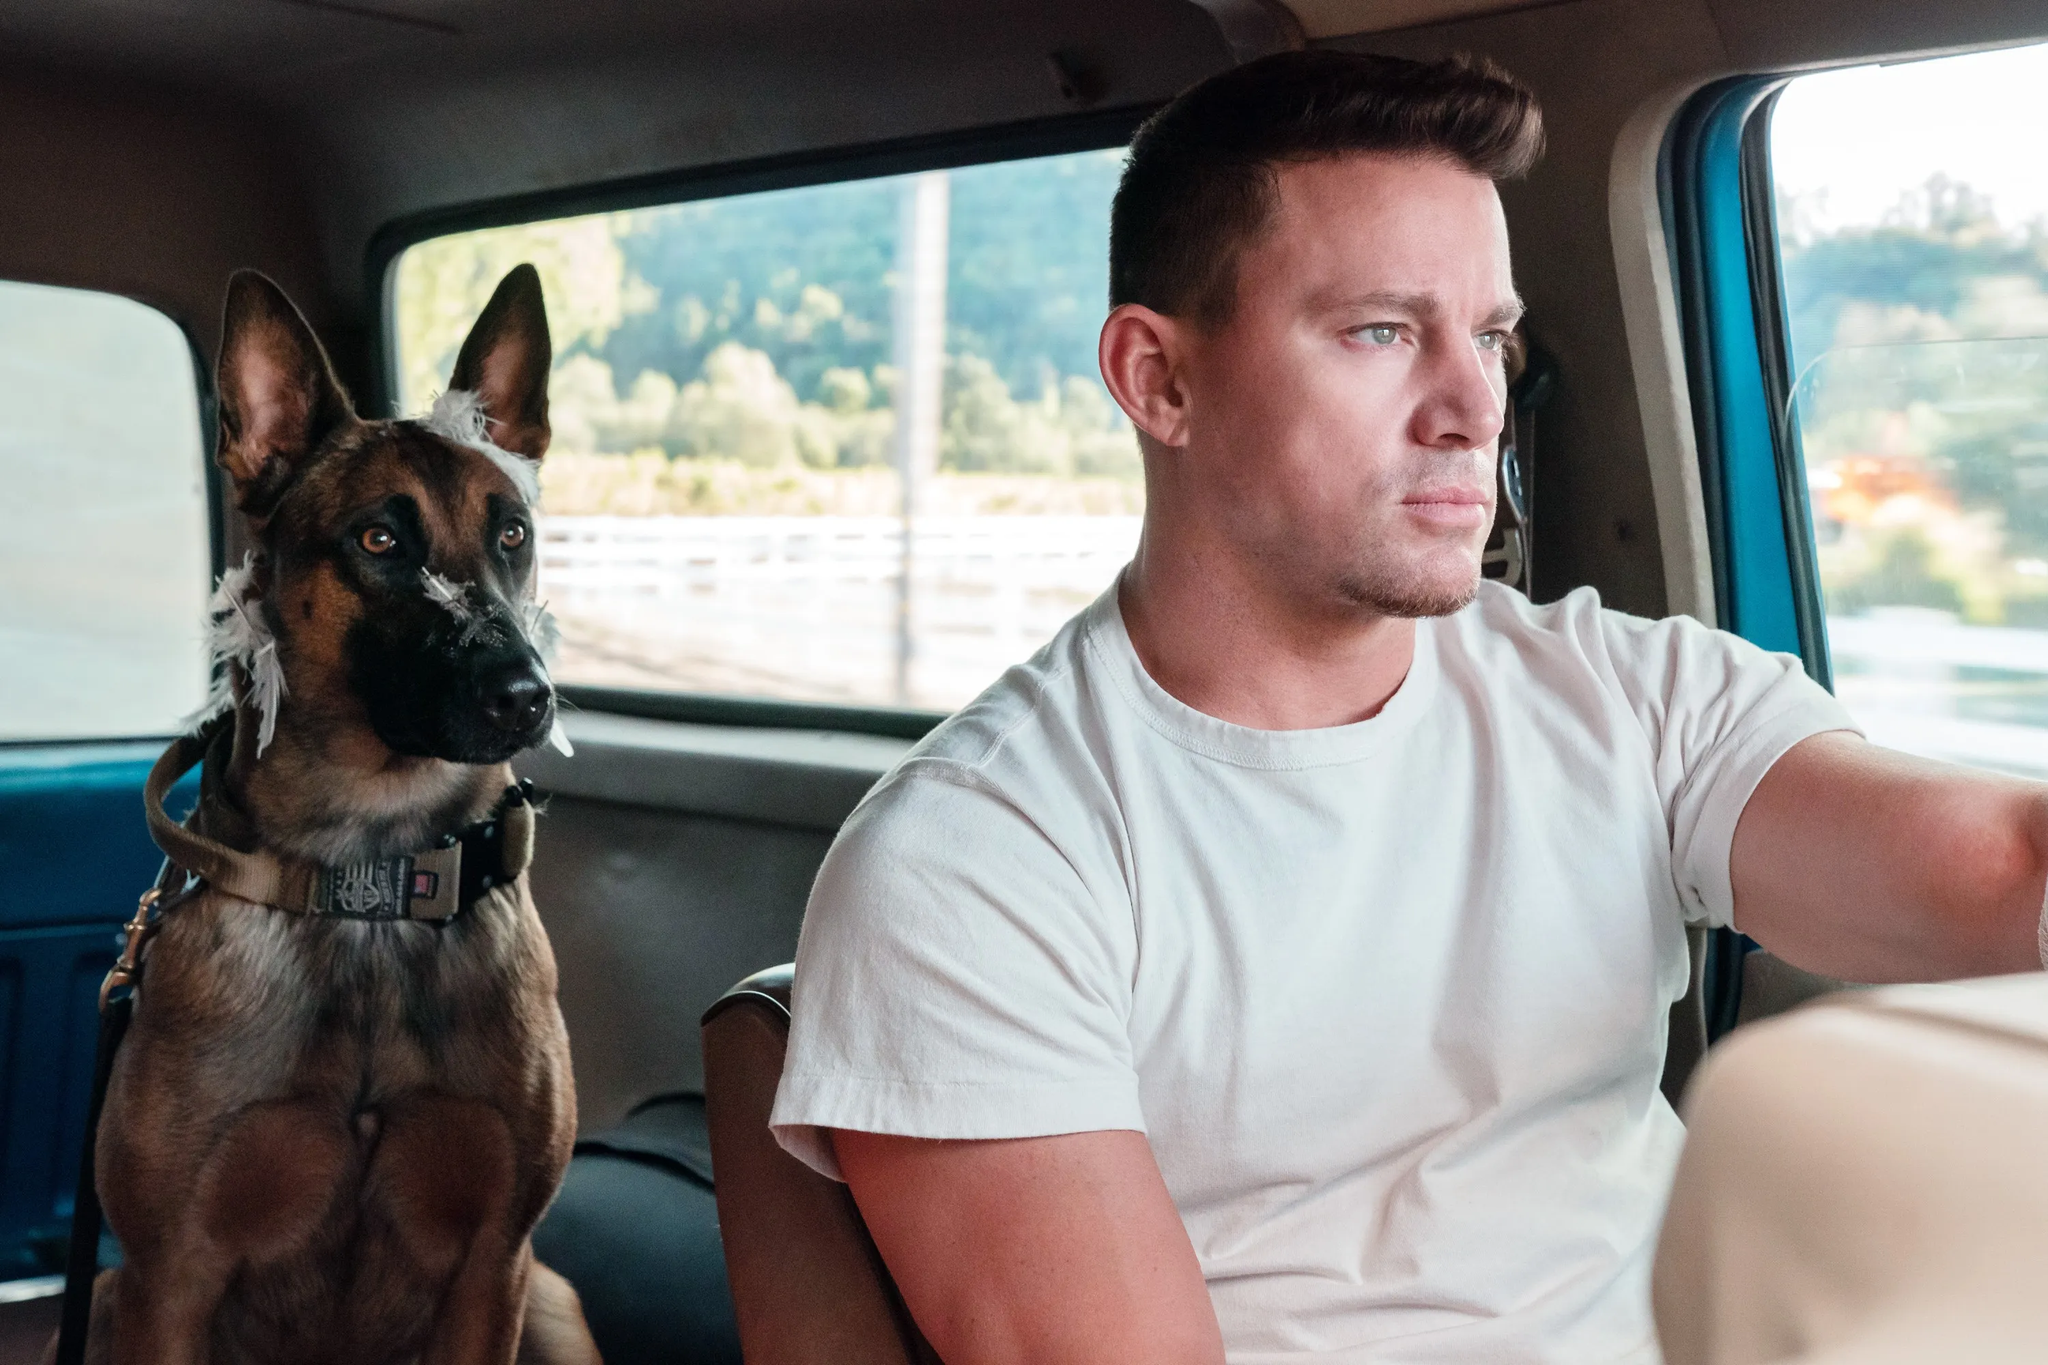Describe a realistic scenario for this image in a short response. The man and his dog are on their way to a friend's house for a weekend visit. They enjoy the quiet drive through scenic backroads, away from the city's hustle. 